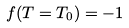Convert formula to latex. <formula><loc_0><loc_0><loc_500><loc_500>f ( T = T _ { 0 } ) = - 1</formula> 